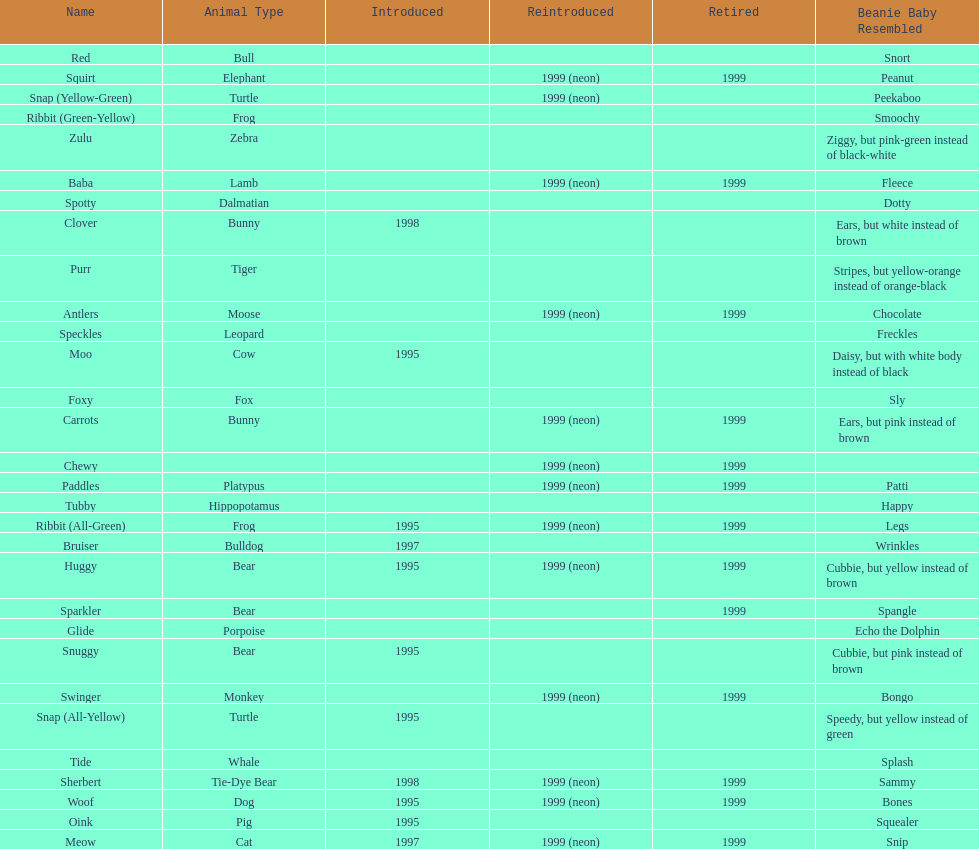Name the only pillow pal that is a dalmatian. Spotty. 